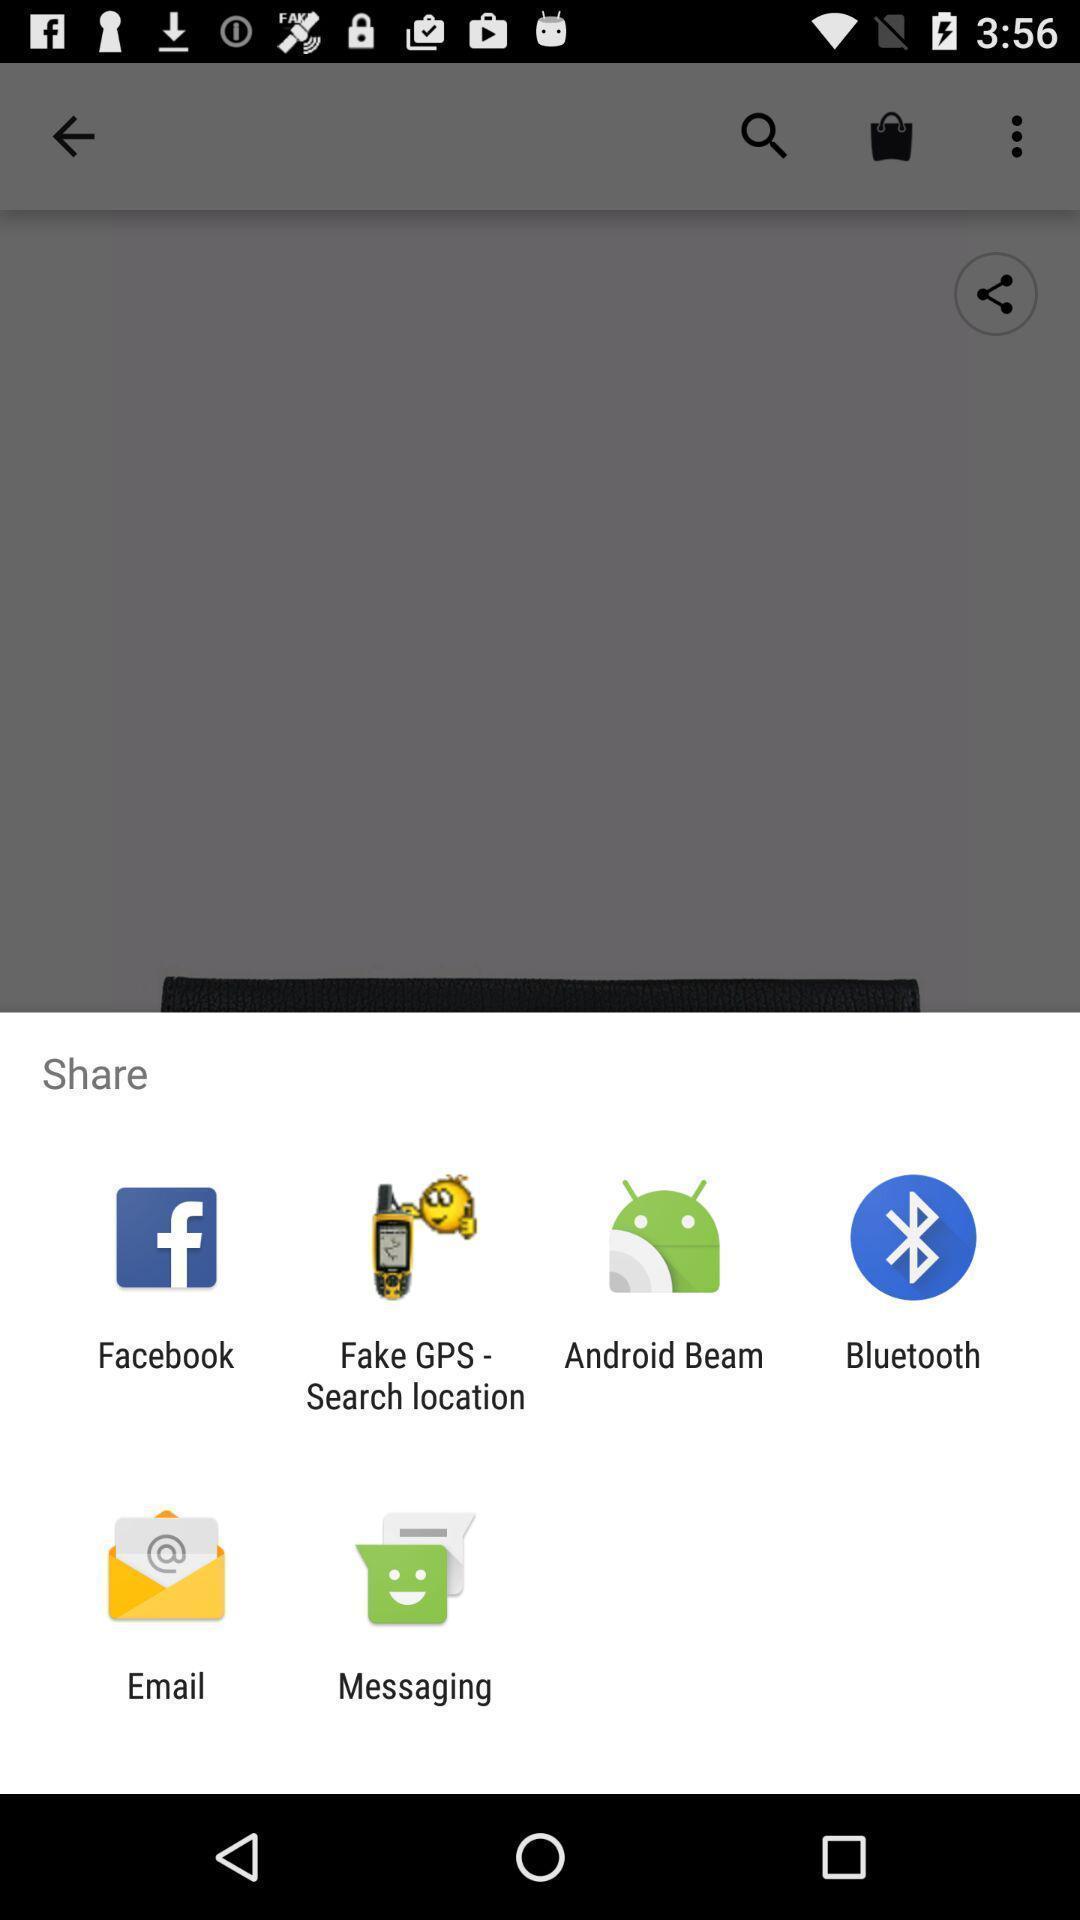Please provide a description for this image. Screen displaying to share using different social applications. 